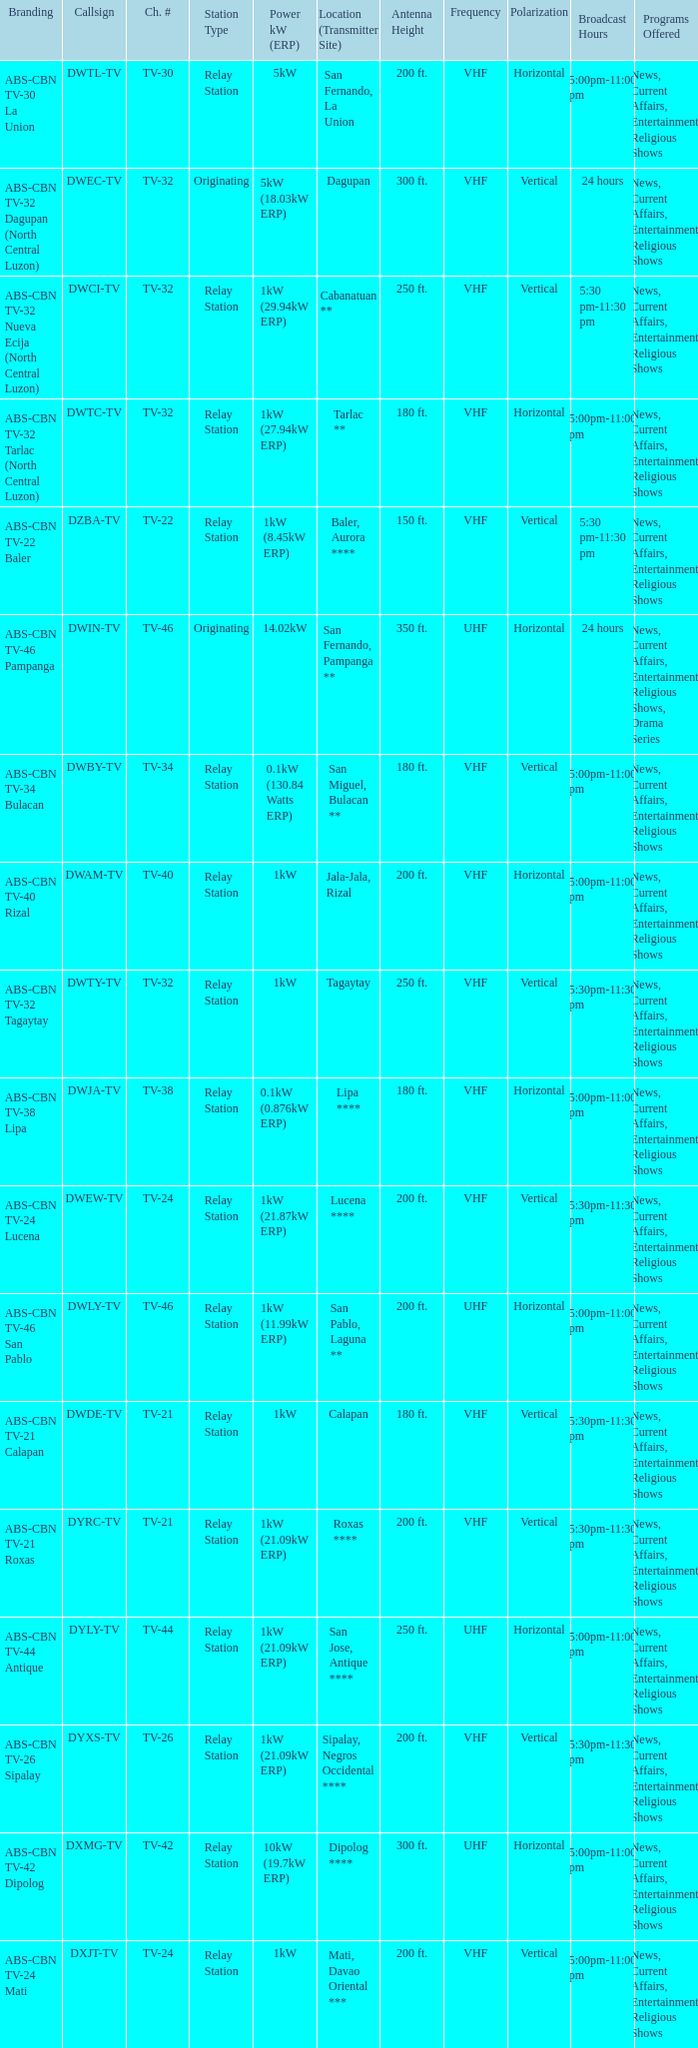What is the station type for the branding ABS-CBN TV-32 Tagaytay? Relay Station. 